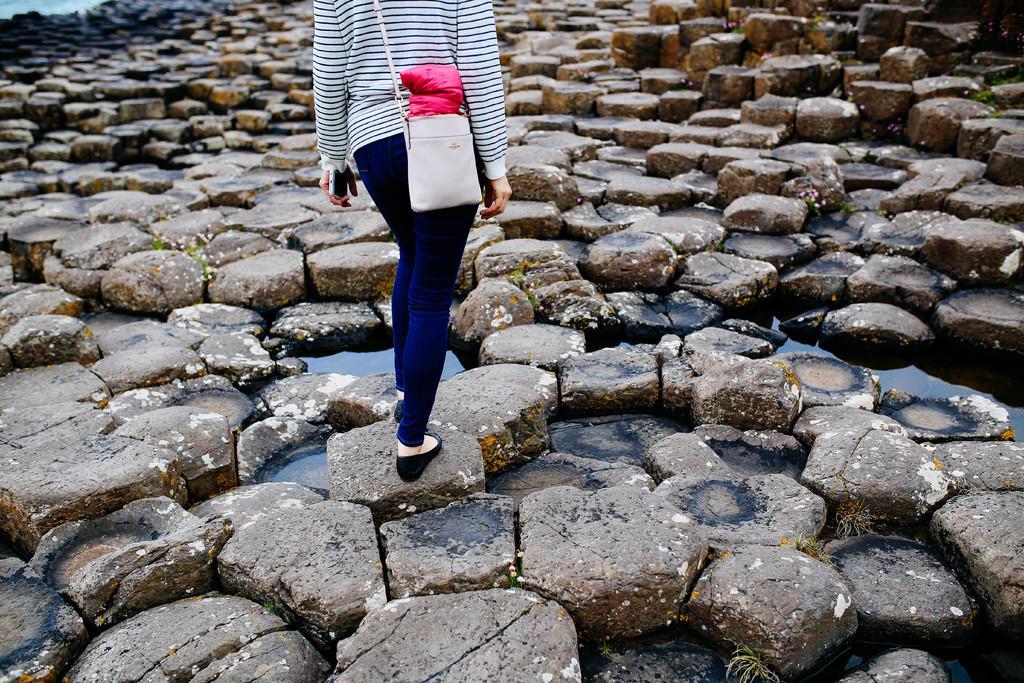Please provide a concise description of this image. In this image we can see a person standing and carrying a bag, there are some stones, water and grass. 